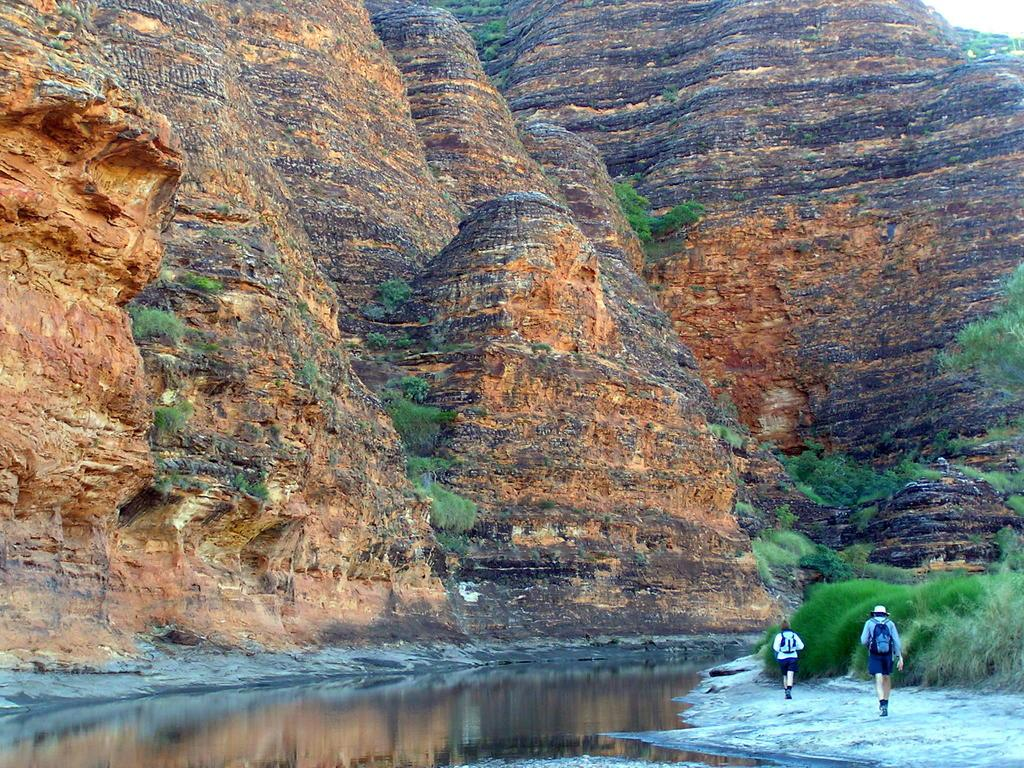How many people are in the image? There are two persons on the right side of the image. What are the persons wearing? The persons are wearing bags. What are the persons doing in the image? The persons are walking. What is located at the bottom of the image? There is a pound at the bottom of the image. What can be seen in the background of the image? There are mountains and trees in the background of the image. What is the limit of the side of the rub in the image? There is no rub or limit mentioned in the image; it features two persons walking with bags. 